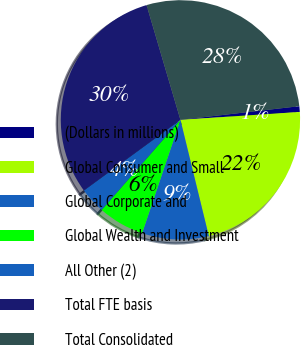<chart> <loc_0><loc_0><loc_500><loc_500><pie_chart><fcel>(Dollars in millions)<fcel>Global Consumer and Small<fcel>Global Corporate and<fcel>Global Wealth and Investment<fcel>All Other (2)<fcel>Total FTE basis<fcel>Total Consolidated<nl><fcel>0.77%<fcel>22.24%<fcel>9.0%<fcel>6.25%<fcel>3.51%<fcel>30.49%<fcel>27.75%<nl></chart> 